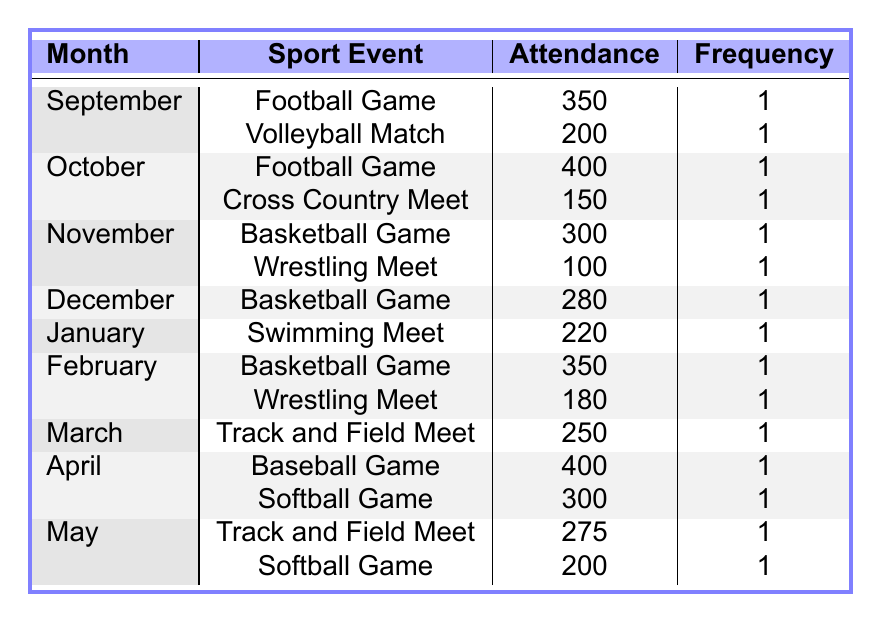What is the total attendance for sport events in September? To find the total attendance for September, I add the attendance of all sport events listed for that month: Football Game (350) + Volleyball Match (200) = 550.
Answer: 550 Which month had the highest attendance for a single sport event? By checking each month's highest attendance values, October had the highest attendance at 400 for the Football Game and also in April for the Baseball Game, so the highest attendance for a single event is 400.
Answer: 400 Is there a sport event in May that had more than 250 attendees? In May, the Track and Field Meet had 275 attendees, which is more than 250, making the statement true.
Answer: Yes What is the average attendance across all the sport events in December? In December, there is only one sport event listed, which is a Basketball Game with an attendance of 280. Thus, the average attendance is also 280, since there is no other event to calculate an average from.
Answer: 280 Which two months had basketball games, and what were their attendance figures? The months with basketball games are November with an attendance of 300, and February with an attendance of 350. Therefore, the attendance figures are 300 and 350 for November and February, respectively.
Answer: November: 300, February: 350 How many wrestling meets had an attendance of less than 200? There were two wrestling meets: one in November with 100 attendees and another in February with 180 attendees. Both are less than 200. Therefore, the total number of wrestling meets with fewer than 200 attendees is 2.
Answer: 2 What sport event in April had less attendance, baseball or softball? In April, the Baseball Game had an attendance of 400, while the Softball Game had an attendance of 300. Since 300 is less than 400, the Softball Game had less attendance.
Answer: Softball Game Which month had the least prevalence of attendance? To evaluate prevalence, we count the number of sport events per month. September, October, November, December, January, February, March, April, and May each have 1 or 2 events, but December and January had fewer events (1 each) than others. Being the only events listed makes them the least prevalent.
Answer: December, January How much more was the attendance at the April Baseball Game compared to February's Basketball Game? The attendance for the April Baseball Game was 400, and for the February Basketball Game, it was 350. The difference is calculated as 400 - 350 = 50.
Answer: 50 